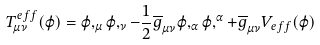<formula> <loc_0><loc_0><loc_500><loc_500>T _ { \mu \nu } ^ { e f f } ( \varphi ) = \varphi , _ { \mu } \varphi , _ { \nu } - \frac { 1 } { 2 } \overline { g } _ { \mu \nu } \varphi , _ { \alpha } \varphi , ^ { \alpha } + \overline { g } _ { \mu \nu } V _ { e f f } ( \varphi )</formula> 